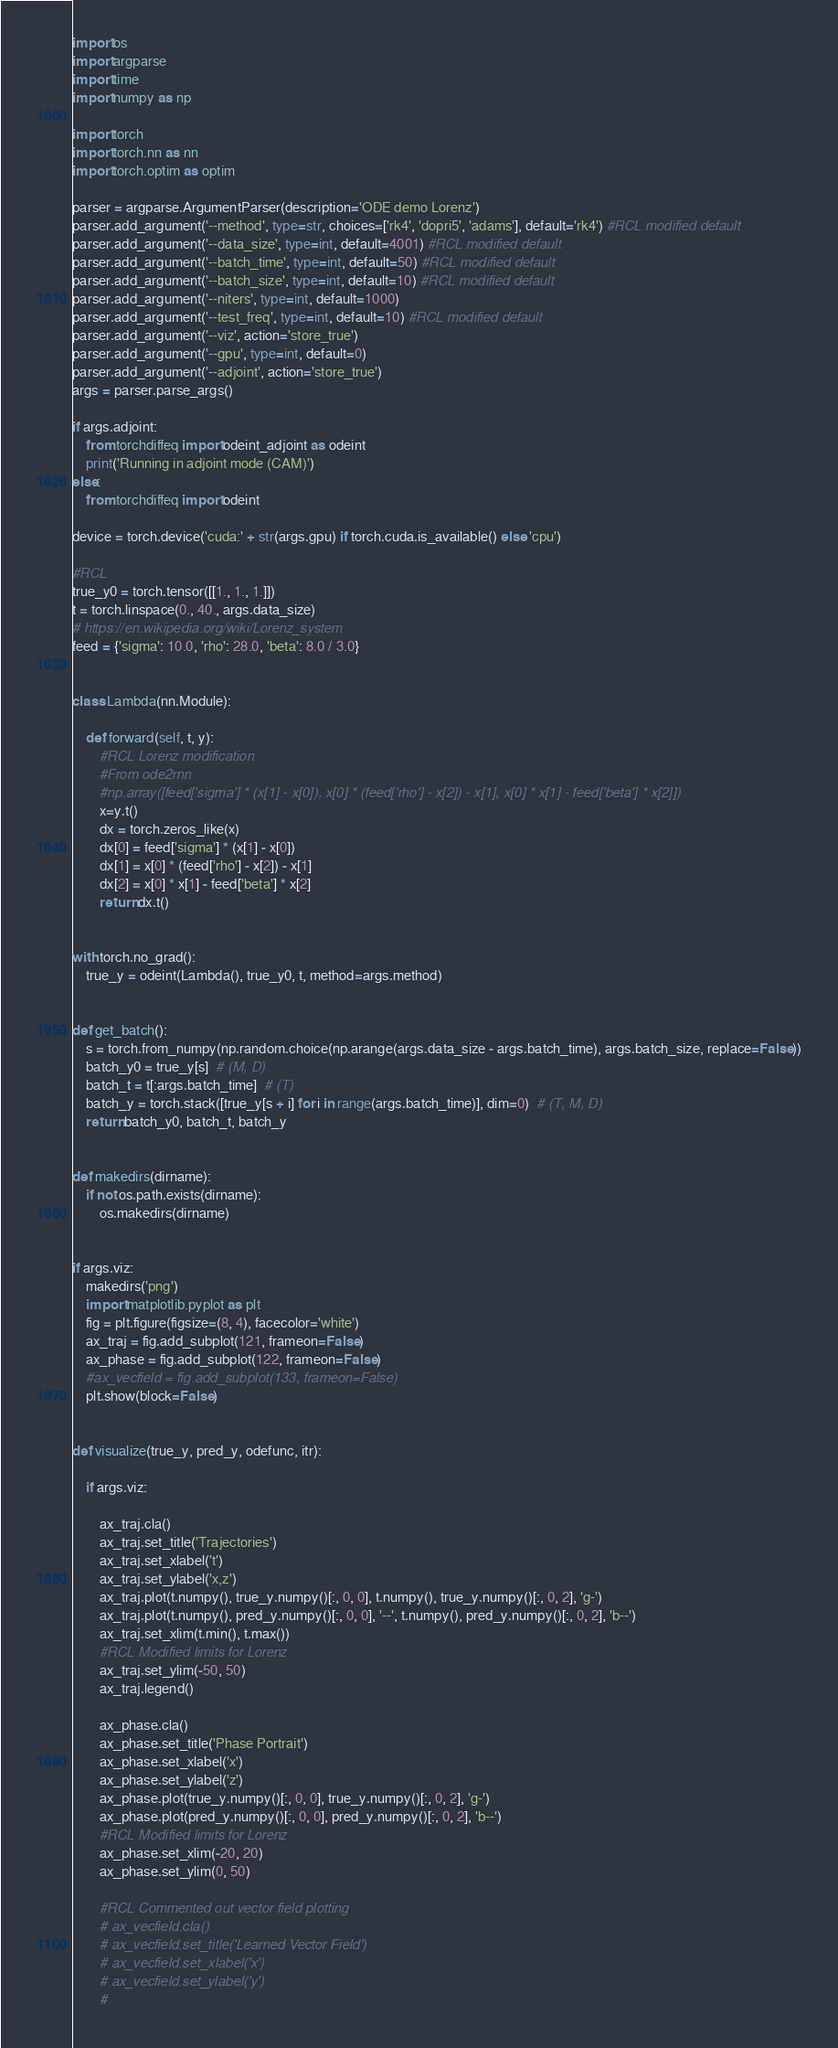Convert code to text. <code><loc_0><loc_0><loc_500><loc_500><_Python_>import os
import argparse
import time
import numpy as np

import torch
import torch.nn as nn
import torch.optim as optim

parser = argparse.ArgumentParser(description='ODE demo Lorenz')
parser.add_argument('--method', type=str, choices=['rk4', 'dopri5', 'adams'], default='rk4') #RCL modified default
parser.add_argument('--data_size', type=int, default=4001) #RCL modified default
parser.add_argument('--batch_time', type=int, default=50) #RCL modified default
parser.add_argument('--batch_size', type=int, default=10) #RCL modified default
parser.add_argument('--niters', type=int, default=1000)
parser.add_argument('--test_freq', type=int, default=10) #RCL modified default
parser.add_argument('--viz', action='store_true')
parser.add_argument('--gpu', type=int, default=0)
parser.add_argument('--adjoint', action='store_true')
args = parser.parse_args()

if args.adjoint:
    from torchdiffeq import odeint_adjoint as odeint
    print('Running in adjoint mode (CAM)')
else:
    from torchdiffeq import odeint

device = torch.device('cuda:' + str(args.gpu) if torch.cuda.is_available() else 'cpu')

#RCL
true_y0 = torch.tensor([[1., 1., 1.]])
t = torch.linspace(0., 40., args.data_size)
# https://en.wikipedia.org/wiki/Lorenz_system
feed = {'sigma': 10.0, 'rho': 28.0, 'beta': 8.0 / 3.0}


class Lambda(nn.Module):

    def forward(self, t, y):
        #RCL Lorenz modification
        #From ode2rnn
        #np.array([feed['sigma'] * (x[1] - x[0]), x[0] * (feed['rho'] - x[2]) - x[1], x[0] * x[1] - feed['beta'] * x[2]])
        x=y.t()
        dx = torch.zeros_like(x)
        dx[0] = feed['sigma'] * (x[1] - x[0])
        dx[1] = x[0] * (feed['rho'] - x[2]) - x[1]
        dx[2] = x[0] * x[1] - feed['beta'] * x[2]
        return dx.t()


with torch.no_grad():
    true_y = odeint(Lambda(), true_y0, t, method=args.method)


def get_batch():
    s = torch.from_numpy(np.random.choice(np.arange(args.data_size - args.batch_time), args.batch_size, replace=False))
    batch_y0 = true_y[s]  # (M, D)
    batch_t = t[:args.batch_time]  # (T)
    batch_y = torch.stack([true_y[s + i] for i in range(args.batch_time)], dim=0)  # (T, M, D)
    return batch_y0, batch_t, batch_y


def makedirs(dirname):
    if not os.path.exists(dirname):
        os.makedirs(dirname)


if args.viz:
    makedirs('png')
    import matplotlib.pyplot as plt
    fig = plt.figure(figsize=(8, 4), facecolor='white')
    ax_traj = fig.add_subplot(121, frameon=False)
    ax_phase = fig.add_subplot(122, frameon=False)
    #ax_vecfield = fig.add_subplot(133, frameon=False)
    plt.show(block=False)


def visualize(true_y, pred_y, odefunc, itr):

    if args.viz:

        ax_traj.cla()
        ax_traj.set_title('Trajectories')
        ax_traj.set_xlabel('t')
        ax_traj.set_ylabel('x,z')
        ax_traj.plot(t.numpy(), true_y.numpy()[:, 0, 0], t.numpy(), true_y.numpy()[:, 0, 2], 'g-')
        ax_traj.plot(t.numpy(), pred_y.numpy()[:, 0, 0], '--', t.numpy(), pred_y.numpy()[:, 0, 2], 'b--')
        ax_traj.set_xlim(t.min(), t.max())
        #RCL Modified limits for Lorenz
        ax_traj.set_ylim(-50, 50)
        ax_traj.legend()

        ax_phase.cla()
        ax_phase.set_title('Phase Portrait')
        ax_phase.set_xlabel('x')
        ax_phase.set_ylabel('z')
        ax_phase.plot(true_y.numpy()[:, 0, 0], true_y.numpy()[:, 0, 2], 'g-')
        ax_phase.plot(pred_y.numpy()[:, 0, 0], pred_y.numpy()[:, 0, 2], 'b--')
        #RCL Modified limits for Lorenz
        ax_phase.set_xlim(-20, 20)
        ax_phase.set_ylim(0, 50)

        #RCL Commented out vector field plotting
        # ax_vecfield.cla()
        # ax_vecfield.set_title('Learned Vector Field')
        # ax_vecfield.set_xlabel('x')
        # ax_vecfield.set_ylabel('y')
        #</code> 